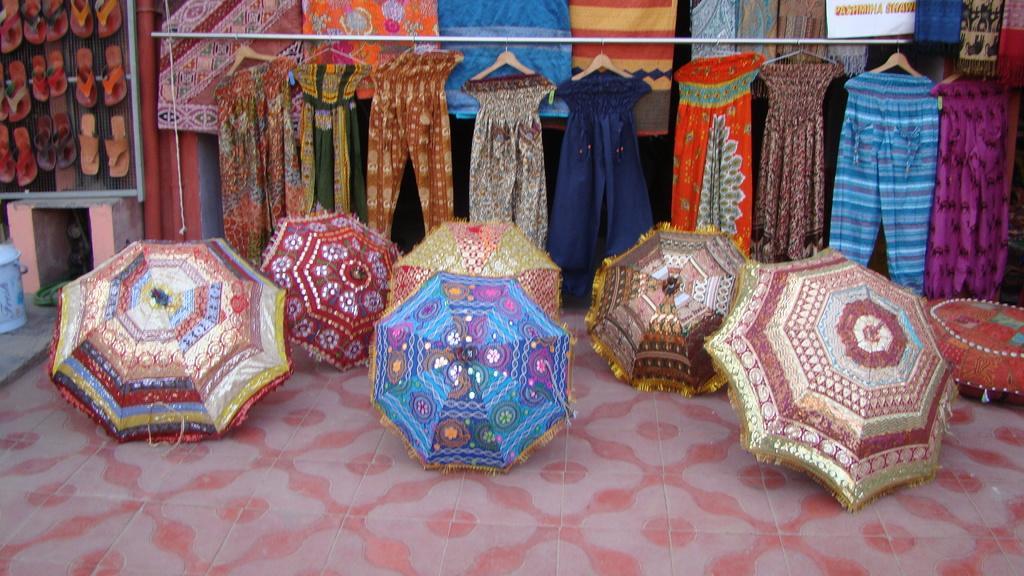In one or two sentences, can you explain what this image depicts? In the center of the image there are umbrellas on the floor. In the background of the image there are clothes, footwear. To the left side of the image there is a blue color bin. 